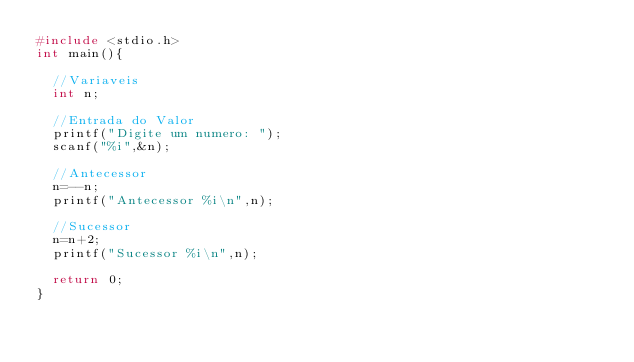<code> <loc_0><loc_0><loc_500><loc_500><_C_>#include <stdio.h>
int main(){
	
	//Variaveis
	int n;
	
	//Entrada do Valor
	printf("Digite um numero: ");
	scanf("%i",&n);
	
	//Antecessor
	n=--n;
	printf("Antecessor %i\n",n);
	
	//Sucessor
	n=n+2;
	printf("Sucessor %i\n",n);
	
	return 0;
}
</code> 